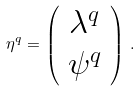Convert formula to latex. <formula><loc_0><loc_0><loc_500><loc_500>\eta ^ { q } = \left ( \begin{array} { c c } \lambda ^ { q } \\ \psi ^ { q } \end{array} \right ) \, .</formula> 